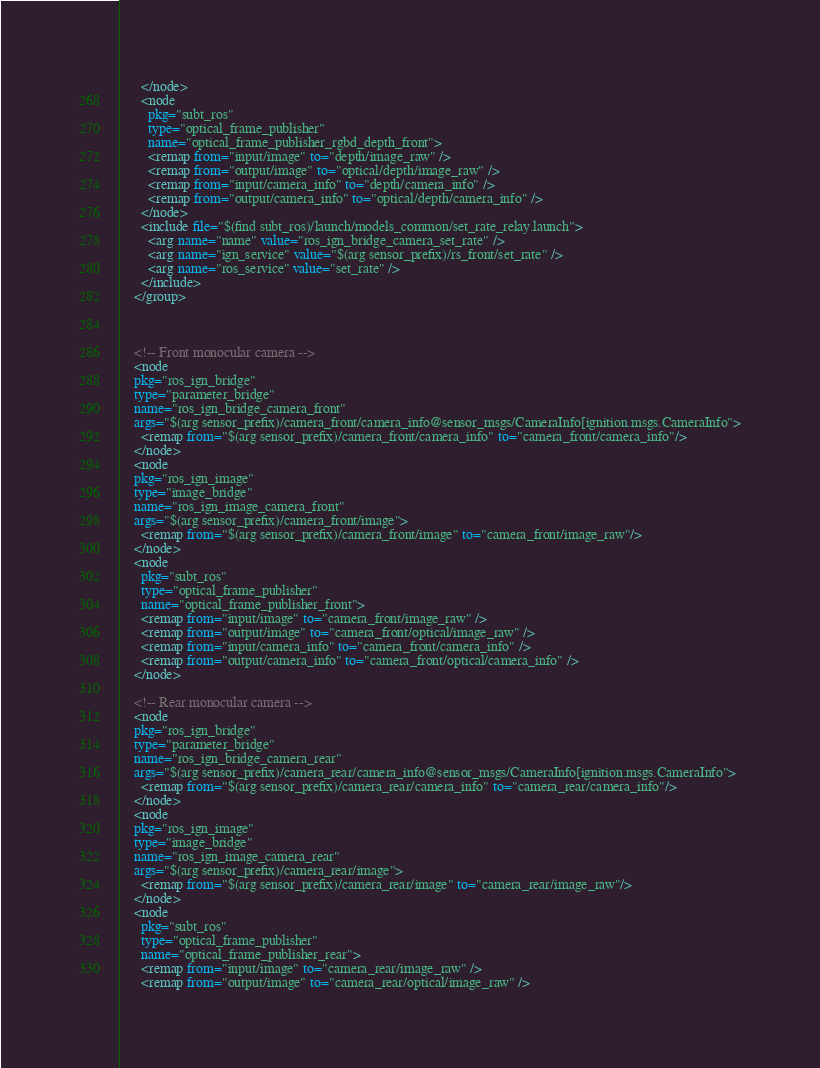<code> <loc_0><loc_0><loc_500><loc_500><_XML_>      </node>
      <node
        pkg="subt_ros"
        type="optical_frame_publisher"
        name="optical_frame_publisher_rgbd_depth_front">
        <remap from="input/image" to="depth/image_raw" />
        <remap from="output/image" to="optical/depth/image_raw" />
        <remap from="input/camera_info" to="depth/camera_info" />
        <remap from="output/camera_info" to="optical/depth/camera_info" />
      </node>
      <include file="$(find subt_ros)/launch/models_common/set_rate_relay.launch">
        <arg name="name" value="ros_ign_bridge_camera_set_rate" />
        <arg name="ign_service" value="$(arg sensor_prefix)/rs_front/set_rate" />
        <arg name="ros_service" value="set_rate" />
      </include>
    </group>



    <!-- Front monocular camera -->
    <node
	pkg="ros_ign_bridge"
	type="parameter_bridge"
	name="ros_ign_bridge_camera_front"
	args="$(arg sensor_prefix)/camera_front/camera_info@sensor_msgs/CameraInfo[ignition.msgs.CameraInfo">
      <remap from="$(arg sensor_prefix)/camera_front/camera_info" to="camera_front/camera_info"/>
    </node>
    <node
	pkg="ros_ign_image"
	type="image_bridge"
	name="ros_ign_image_camera_front"
	args="$(arg sensor_prefix)/camera_front/image">
      <remap from="$(arg sensor_prefix)/camera_front/image" to="camera_front/image_raw"/>
    </node>
    <node
      pkg="subt_ros"
      type="optical_frame_publisher"
      name="optical_frame_publisher_front">
      <remap from="input/image" to="camera_front/image_raw" />
      <remap from="output/image" to="camera_front/optical/image_raw" />
      <remap from="input/camera_info" to="camera_front/camera_info" />
      <remap from="output/camera_info" to="camera_front/optical/camera_info" />
    </node>
    
    <!-- Rear monocular camera -->
    <node
	pkg="ros_ign_bridge"
	type="parameter_bridge"
	name="ros_ign_bridge_camera_rear"
	args="$(arg sensor_prefix)/camera_rear/camera_info@sensor_msgs/CameraInfo[ignition.msgs.CameraInfo">
      <remap from="$(arg sensor_prefix)/camera_rear/camera_info" to="camera_rear/camera_info"/>
    </node>
    <node
	pkg="ros_ign_image"
	type="image_bridge"
	name="ros_ign_image_camera_rear"
	args="$(arg sensor_prefix)/camera_rear/image">
      <remap from="$(arg sensor_prefix)/camera_rear/image" to="camera_rear/image_raw"/>
    </node>
    <node
      pkg="subt_ros"
      type="optical_frame_publisher"
      name="optical_frame_publisher_rear">
      <remap from="input/image" to="camera_rear/image_raw" />
      <remap from="output/image" to="camera_rear/optical/image_raw" /></code> 